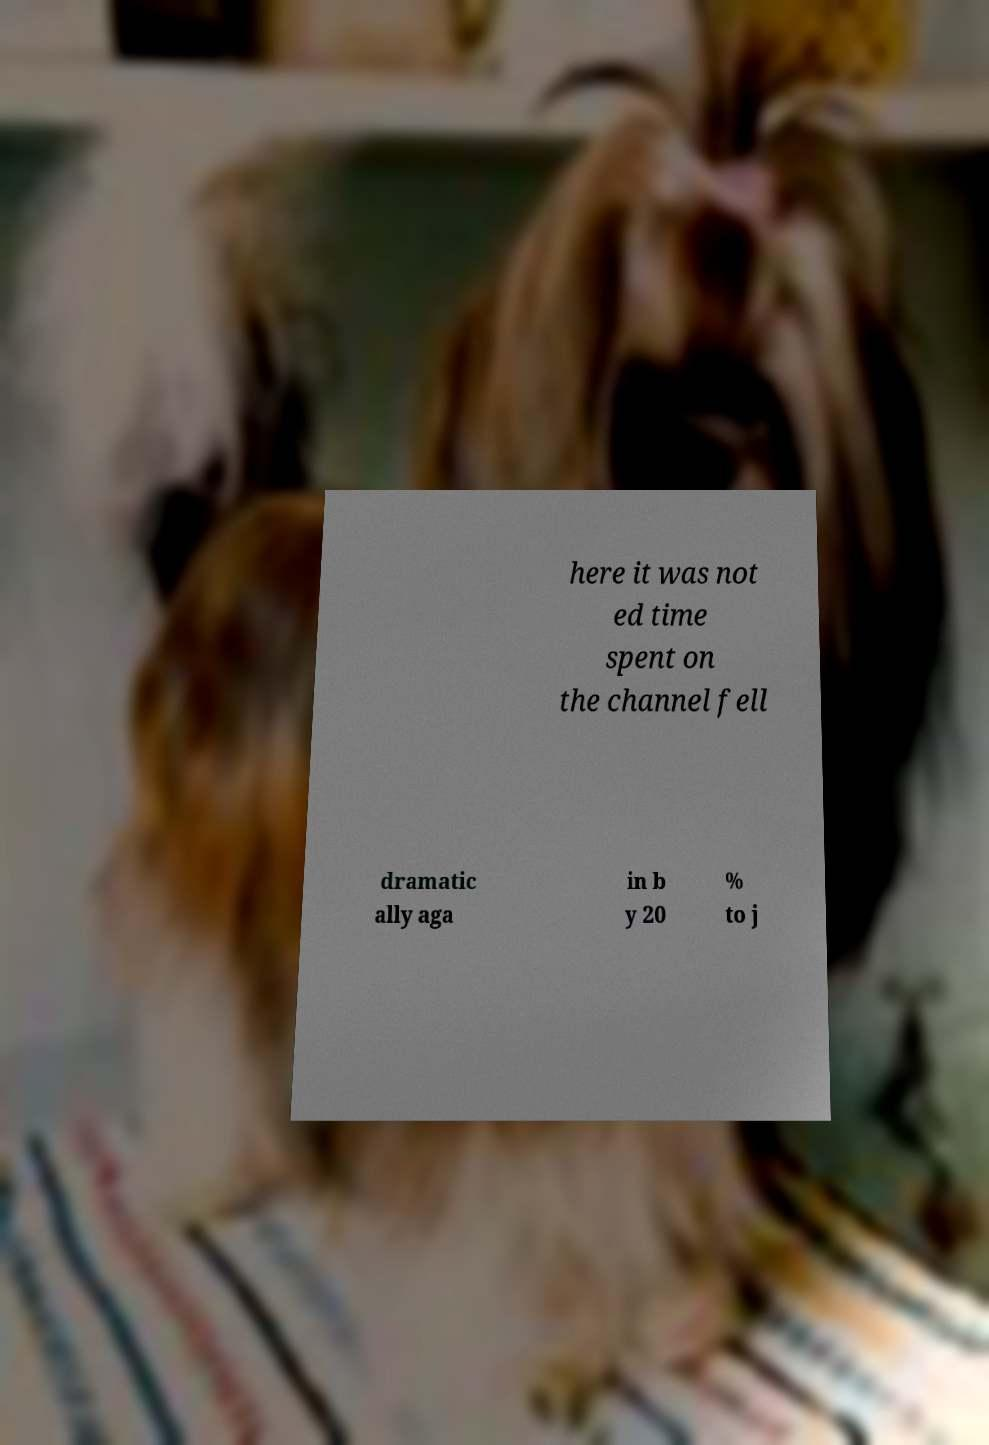Can you accurately transcribe the text from the provided image for me? here it was not ed time spent on the channel fell dramatic ally aga in b y 20 % to j 